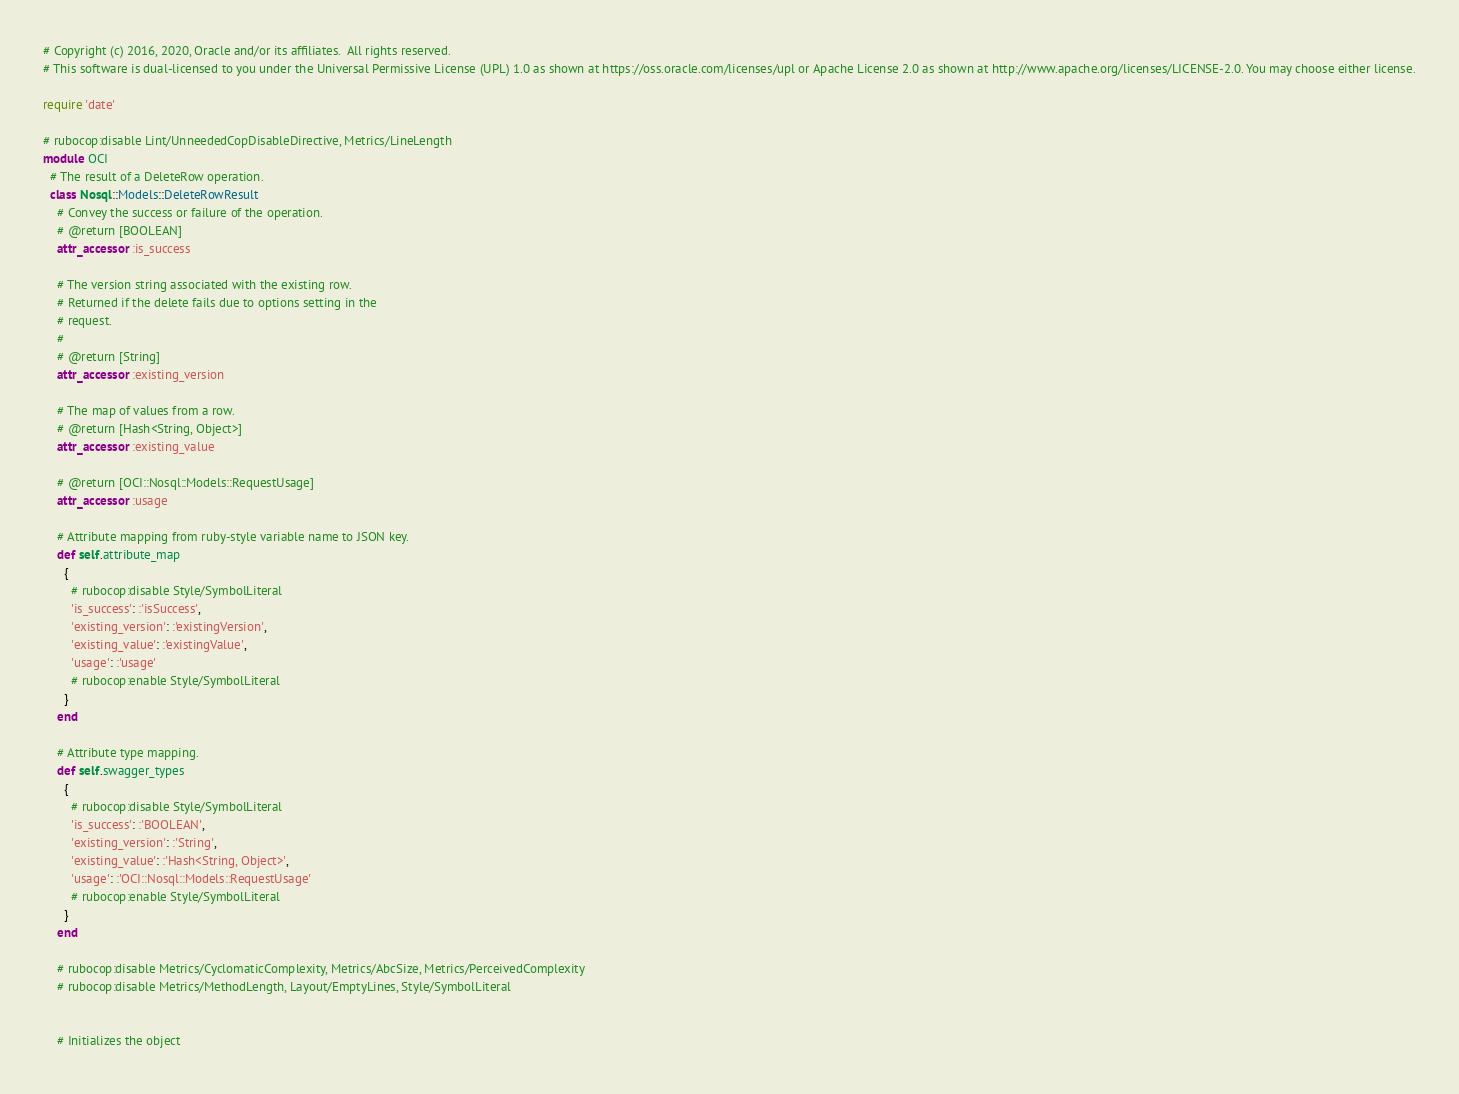Convert code to text. <code><loc_0><loc_0><loc_500><loc_500><_Ruby_># Copyright (c) 2016, 2020, Oracle and/or its affiliates.  All rights reserved.
# This software is dual-licensed to you under the Universal Permissive License (UPL) 1.0 as shown at https://oss.oracle.com/licenses/upl or Apache License 2.0 as shown at http://www.apache.org/licenses/LICENSE-2.0. You may choose either license.

require 'date'

# rubocop:disable Lint/UnneededCopDisableDirective, Metrics/LineLength
module OCI
  # The result of a DeleteRow operation.
  class Nosql::Models::DeleteRowResult
    # Convey the success or failure of the operation.
    # @return [BOOLEAN]
    attr_accessor :is_success

    # The version string associated with the existing row.
    # Returned if the delete fails due to options setting in the
    # request.
    #
    # @return [String]
    attr_accessor :existing_version

    # The map of values from a row.
    # @return [Hash<String, Object>]
    attr_accessor :existing_value

    # @return [OCI::Nosql::Models::RequestUsage]
    attr_accessor :usage

    # Attribute mapping from ruby-style variable name to JSON key.
    def self.attribute_map
      {
        # rubocop:disable Style/SymbolLiteral
        'is_success': :'isSuccess',
        'existing_version': :'existingVersion',
        'existing_value': :'existingValue',
        'usage': :'usage'
        # rubocop:enable Style/SymbolLiteral
      }
    end

    # Attribute type mapping.
    def self.swagger_types
      {
        # rubocop:disable Style/SymbolLiteral
        'is_success': :'BOOLEAN',
        'existing_version': :'String',
        'existing_value': :'Hash<String, Object>',
        'usage': :'OCI::Nosql::Models::RequestUsage'
        # rubocop:enable Style/SymbolLiteral
      }
    end

    # rubocop:disable Metrics/CyclomaticComplexity, Metrics/AbcSize, Metrics/PerceivedComplexity
    # rubocop:disable Metrics/MethodLength, Layout/EmptyLines, Style/SymbolLiteral


    # Initializes the object</code> 